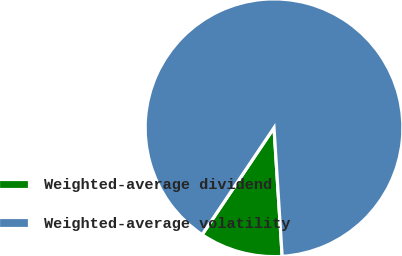Convert chart. <chart><loc_0><loc_0><loc_500><loc_500><pie_chart><fcel>Weighted-average dividend<fcel>Weighted-average volatility<nl><fcel>10.43%<fcel>89.57%<nl></chart> 